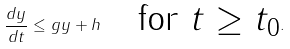<formula> <loc_0><loc_0><loc_500><loc_500>\frac { d y } { d t } \leq g y + h \quad \text {for $t\geq t_{0}$} .</formula> 